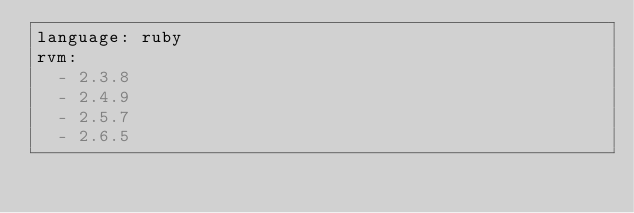Convert code to text. <code><loc_0><loc_0><loc_500><loc_500><_YAML_>language: ruby
rvm:
  - 2.3.8
  - 2.4.9
  - 2.5.7
  - 2.6.5
</code> 